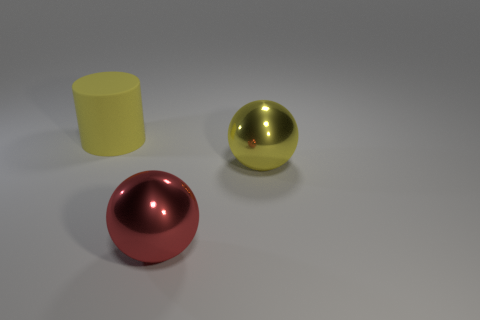Add 2 purple metal cylinders. How many objects exist? 5 Subtract all cylinders. How many objects are left? 2 Add 2 small green spheres. How many small green spheres exist? 2 Subtract 0 purple blocks. How many objects are left? 3 Subtract all big red metallic balls. Subtract all big yellow matte balls. How many objects are left? 2 Add 3 large yellow matte things. How many large yellow matte things are left? 4 